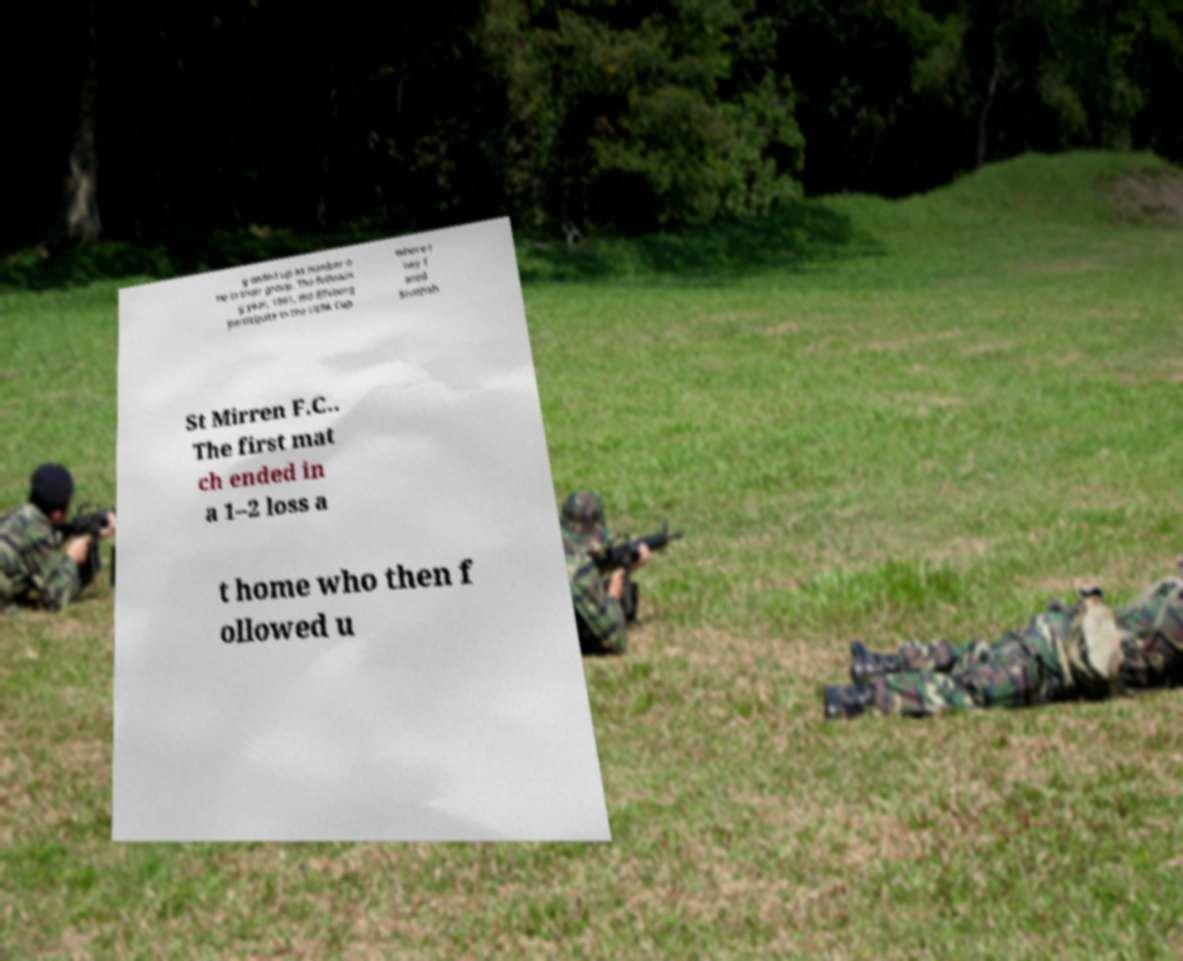There's text embedded in this image that I need extracted. Can you transcribe it verbatim? g ended up as number o ne in their group. The followin g year, 1981, did Elfsborg participate in the UEFA Cup where t hey f aced Scottish St Mirren F.C.. The first mat ch ended in a 1–2 loss a t home who then f ollowed u 